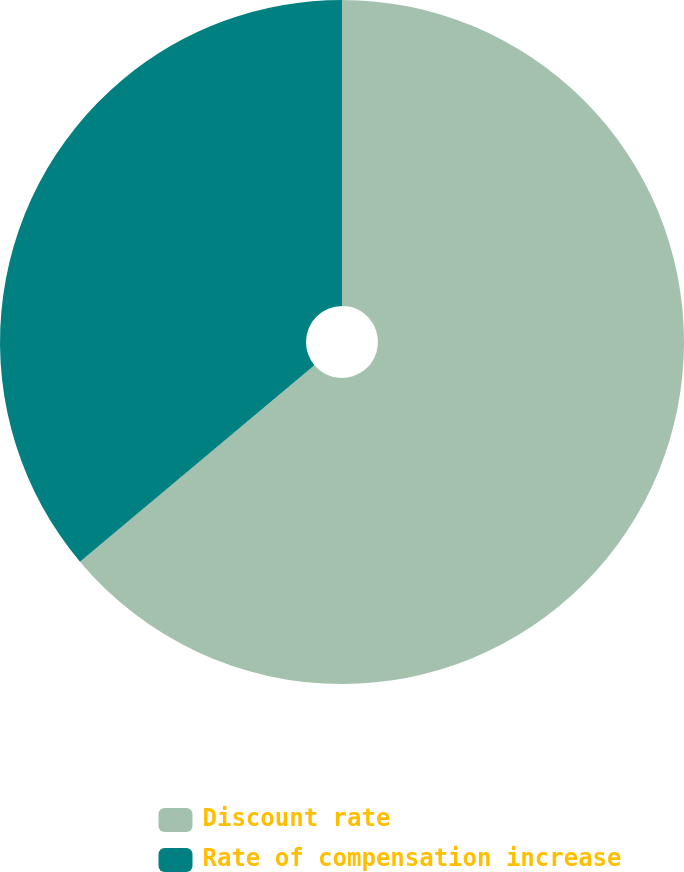Convert chart to OTSL. <chart><loc_0><loc_0><loc_500><loc_500><pie_chart><fcel>Discount rate<fcel>Rate of compensation increase<nl><fcel>63.89%<fcel>36.11%<nl></chart> 